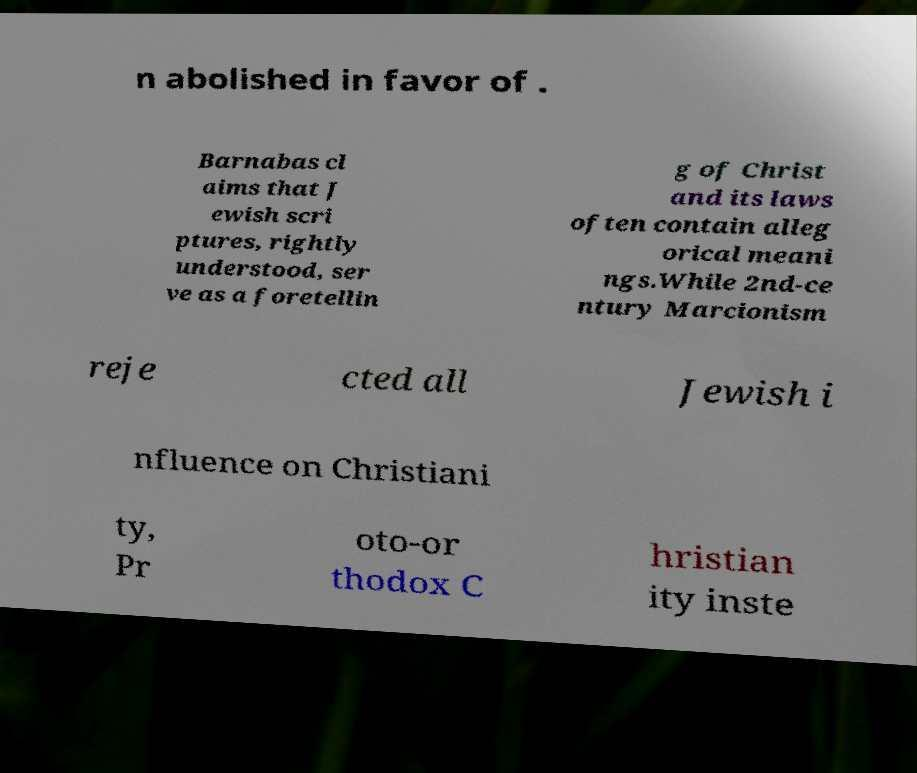What messages or text are displayed in this image? I need them in a readable, typed format. n abolished in favor of . Barnabas cl aims that J ewish scri ptures, rightly understood, ser ve as a foretellin g of Christ and its laws often contain alleg orical meani ngs.While 2nd-ce ntury Marcionism reje cted all Jewish i nfluence on Christiani ty, Pr oto-or thodox C hristian ity inste 